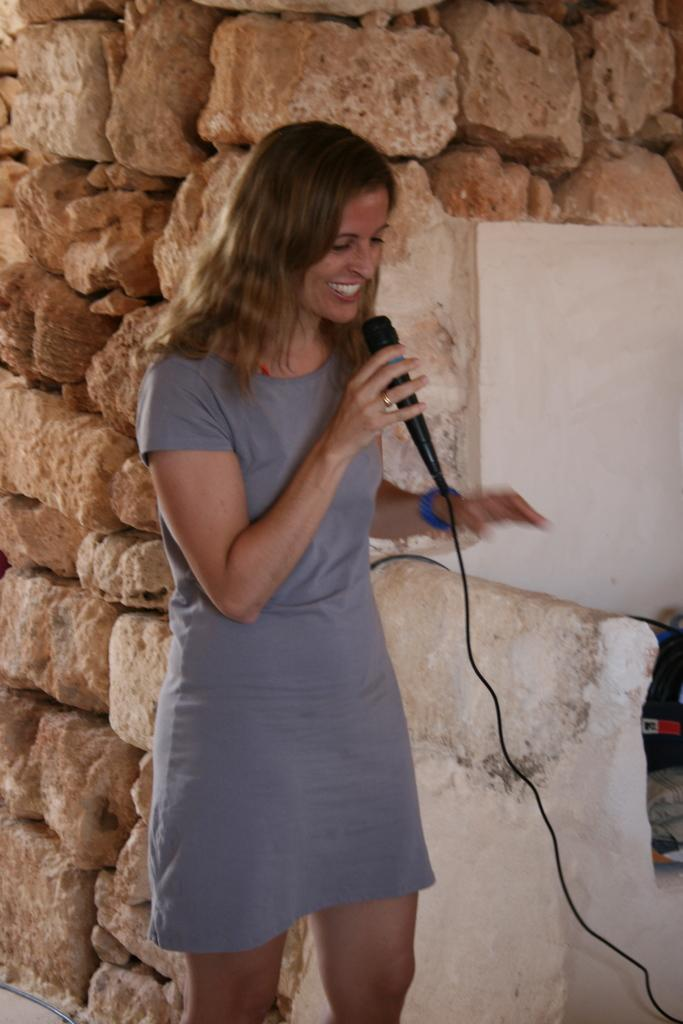Who is present in the image? There is a woman in the image. What is the woman doing in the image? The woman is standing and smiling. What is the woman holding in her hand? The woman is holding a microphone in her hand. What can be seen in the background of the image? There are stones visible in the background of the image. Is the woman getting a haircut in the image? No, there is no indication that the woman is getting a haircut in the image. Why is the woman wearing a mask in the image? There is no mask present in the image; the woman is only holding a microphone. 